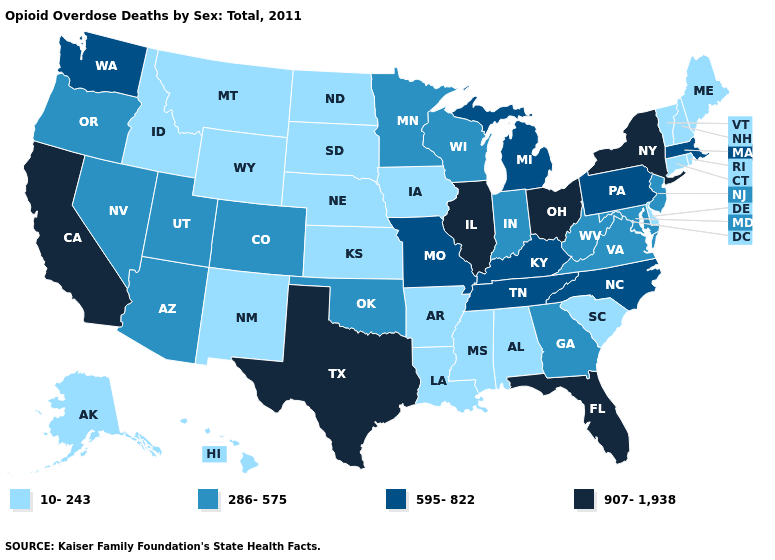Name the states that have a value in the range 595-822?
Short answer required. Kentucky, Massachusetts, Michigan, Missouri, North Carolina, Pennsylvania, Tennessee, Washington. What is the value of South Carolina?
Be succinct. 10-243. Name the states that have a value in the range 595-822?
Concise answer only. Kentucky, Massachusetts, Michigan, Missouri, North Carolina, Pennsylvania, Tennessee, Washington. What is the value of California?
Be succinct. 907-1,938. Which states have the lowest value in the USA?
Concise answer only. Alabama, Alaska, Arkansas, Connecticut, Delaware, Hawaii, Idaho, Iowa, Kansas, Louisiana, Maine, Mississippi, Montana, Nebraska, New Hampshire, New Mexico, North Dakota, Rhode Island, South Carolina, South Dakota, Vermont, Wyoming. Name the states that have a value in the range 10-243?
Short answer required. Alabama, Alaska, Arkansas, Connecticut, Delaware, Hawaii, Idaho, Iowa, Kansas, Louisiana, Maine, Mississippi, Montana, Nebraska, New Hampshire, New Mexico, North Dakota, Rhode Island, South Carolina, South Dakota, Vermont, Wyoming. Name the states that have a value in the range 907-1,938?
Quick response, please. California, Florida, Illinois, New York, Ohio, Texas. What is the value of Kentucky?
Concise answer only. 595-822. Which states have the highest value in the USA?
Be succinct. California, Florida, Illinois, New York, Ohio, Texas. Among the states that border West Virginia , which have the highest value?
Short answer required. Ohio. Name the states that have a value in the range 595-822?
Answer briefly. Kentucky, Massachusetts, Michigan, Missouri, North Carolina, Pennsylvania, Tennessee, Washington. What is the value of Georgia?
Give a very brief answer. 286-575. What is the lowest value in states that border Kansas?
Concise answer only. 10-243. Is the legend a continuous bar?
Answer briefly. No. How many symbols are there in the legend?
Be succinct. 4. 